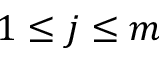<formula> <loc_0><loc_0><loc_500><loc_500>1 \leq j \leq m</formula> 